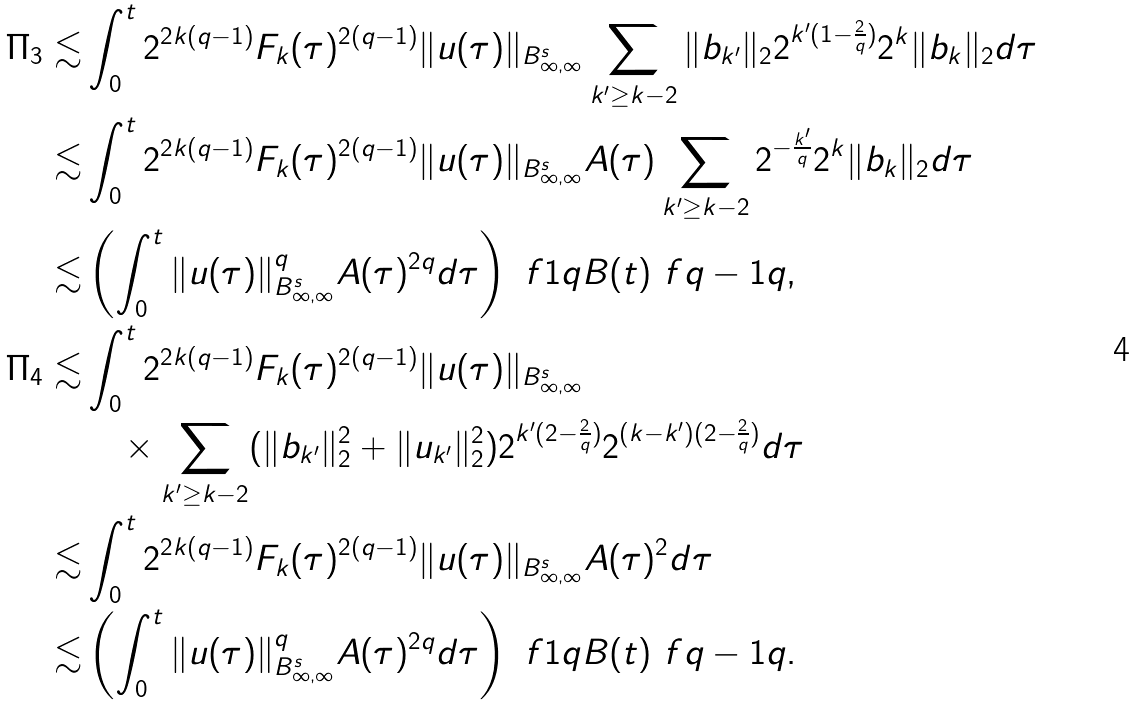<formula> <loc_0><loc_0><loc_500><loc_500>\Pi _ { 3 } \lesssim & \int _ { 0 } ^ { t } 2 ^ { 2 k ( q - 1 ) } F _ { k } ( \tau ) ^ { 2 ( q - 1 ) } \| u ( \tau ) \| _ { B ^ { s } _ { \infty , \infty } } \sum _ { k ^ { \prime } \geq k - 2 } \| b _ { k ^ { \prime } } \| _ { 2 } 2 ^ { k ^ { \prime } ( 1 - \frac { 2 } { q } ) } 2 ^ { k } \| b _ { k } \| _ { 2 } d \tau \\ \lesssim & \int _ { 0 } ^ { t } 2 ^ { 2 k ( q - 1 ) } F _ { k } ( \tau ) ^ { 2 ( q - 1 ) } \| u ( \tau ) \| _ { B ^ { s } _ { \infty , \infty } } A ( \tau ) \sum _ { k ^ { \prime } \geq k - 2 } 2 ^ { - \frac { k ^ { \prime } } q } 2 ^ { k } \| b _ { k } \| _ { 2 } d \tau \\ \lesssim & \left ( \int _ { 0 } ^ { t } \| u ( \tau ) \| _ { B ^ { s } _ { \infty , \infty } } ^ { q } A ( \tau ) ^ { 2 q } d \tau \right ) ^ { \ } f 1 q B ( t ) ^ { \ } f { q - 1 } q , \\ \Pi _ { 4 } \lesssim & \int _ { 0 } ^ { t } 2 ^ { 2 k ( q - 1 ) } F _ { k } ( \tau ) ^ { 2 ( q - 1 ) } \| u ( \tau ) \| _ { B ^ { s } _ { \infty , \infty } } \\ & \quad \times \sum _ { k ^ { \prime } \geq k - 2 } ( \| b _ { k ^ { \prime } } \| _ { 2 } ^ { 2 } + \| u _ { k ^ { \prime } } \| _ { 2 } ^ { 2 } ) 2 ^ { k ^ { \prime } ( 2 - \frac { 2 } { q } ) } 2 ^ { ( k - k ^ { \prime } ) ( 2 - \frac { 2 } { q } ) } d \tau \\ \lesssim & \int _ { 0 } ^ { t } 2 ^ { 2 k ( q - 1 ) } F _ { k } ( \tau ) ^ { 2 ( q - 1 ) } \| u ( \tau ) \| _ { B ^ { s } _ { \infty , \infty } } A ( \tau ) ^ { 2 } d \tau \\ \lesssim & \left ( \int _ { 0 } ^ { t } \| u ( \tau ) \| _ { B ^ { s } _ { \infty , \infty } } ^ { q } A ( \tau ) ^ { 2 q } d \tau \right ) ^ { \ } f 1 q B ( t ) ^ { \ } f { q - 1 } q .</formula> 